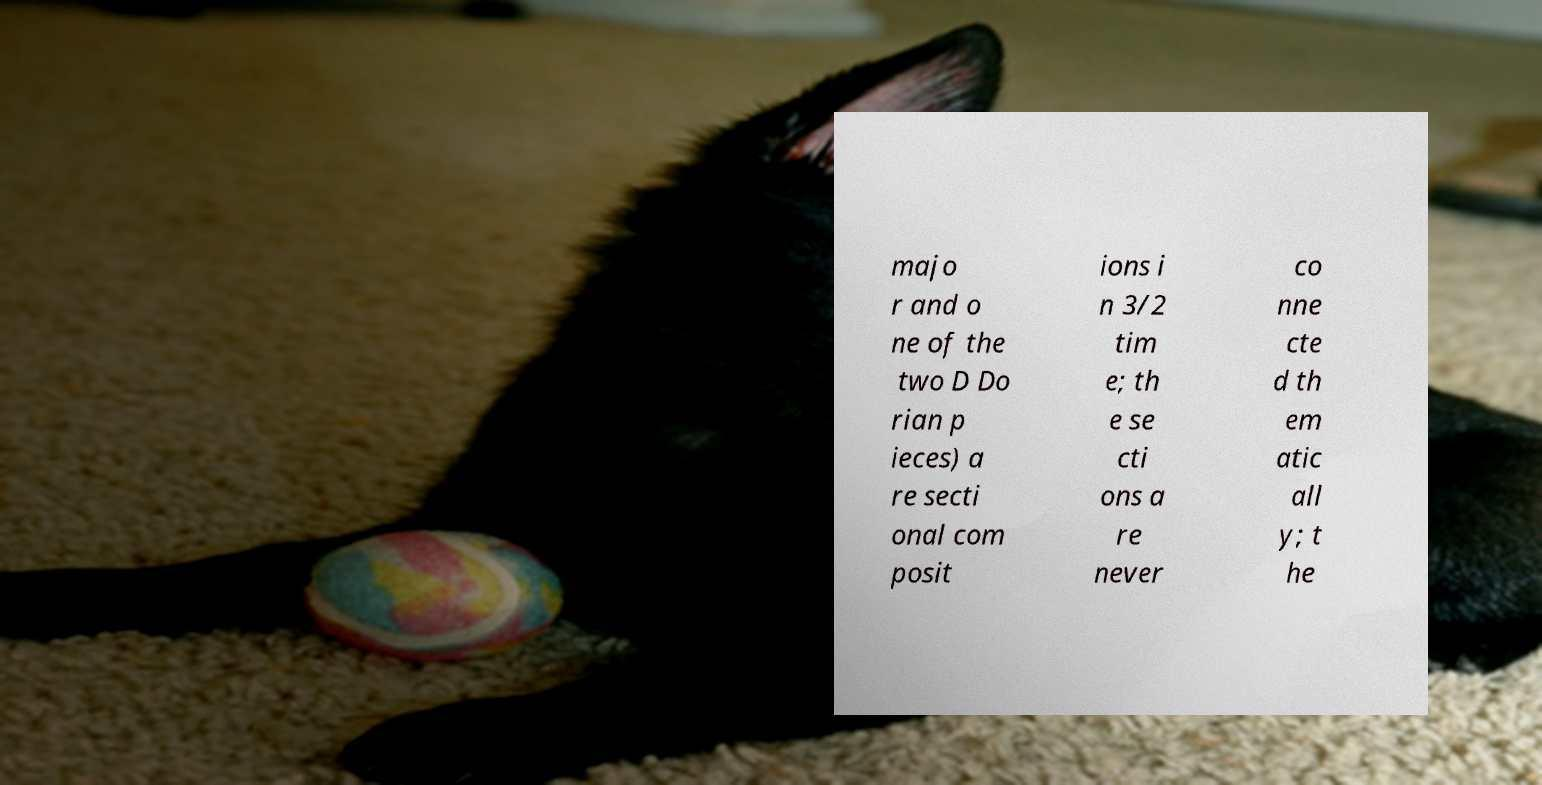Please read and relay the text visible in this image. What does it say? majo r and o ne of the two D Do rian p ieces) a re secti onal com posit ions i n 3/2 tim e; th e se cti ons a re never co nne cte d th em atic all y; t he 